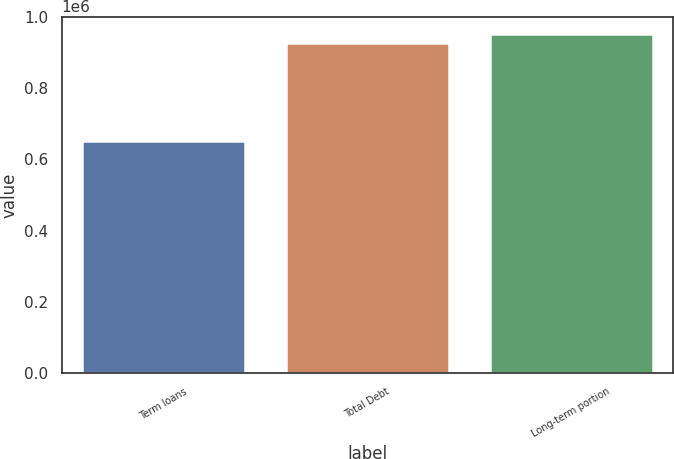<chart> <loc_0><loc_0><loc_500><loc_500><bar_chart><fcel>Term loans<fcel>Total Debt<fcel>Long-term portion<nl><fcel>650000<fcel>925000<fcel>952500<nl></chart> 